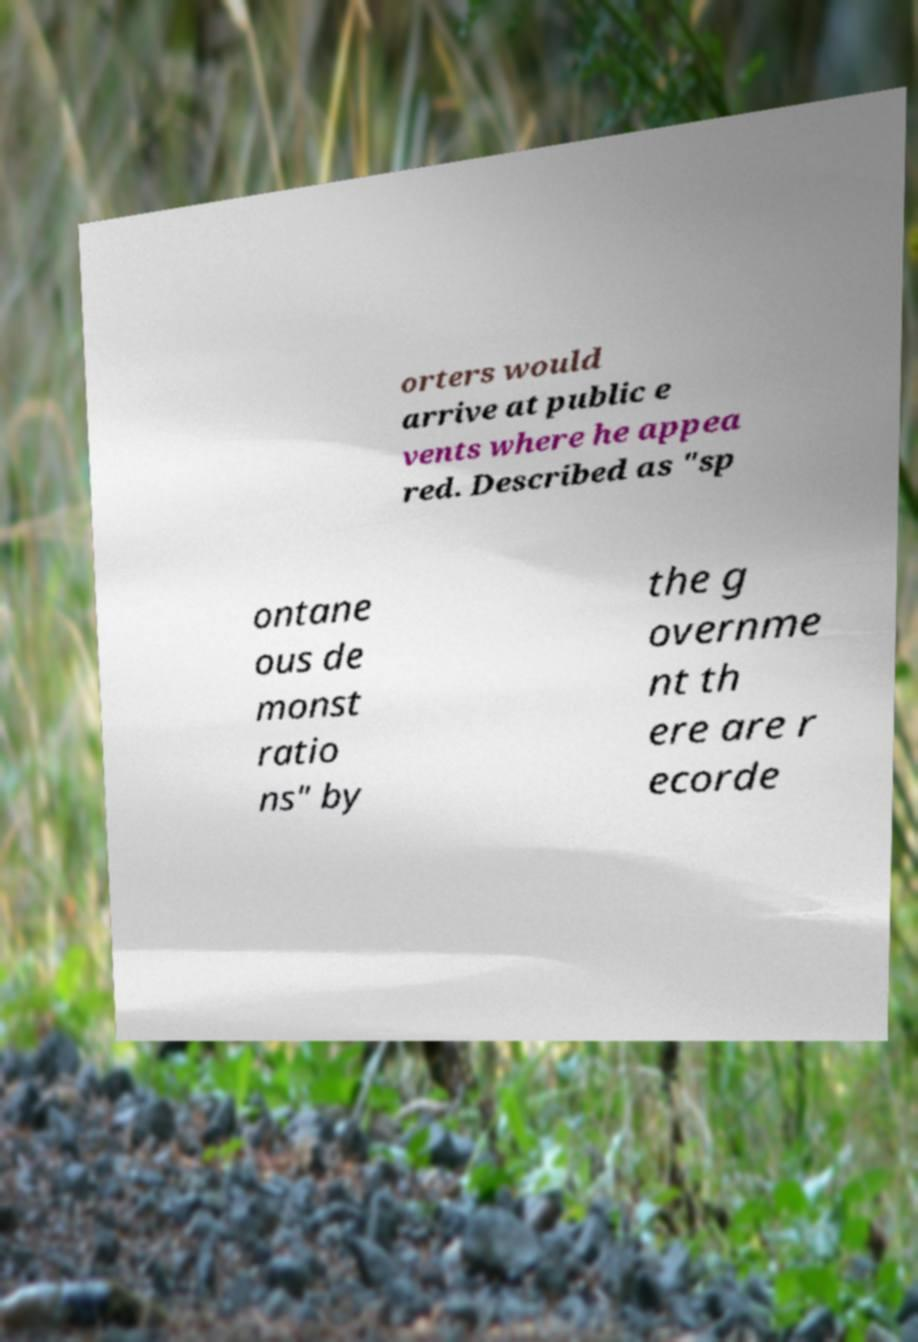Can you read and provide the text displayed in the image?This photo seems to have some interesting text. Can you extract and type it out for me? orters would arrive at public e vents where he appea red. Described as "sp ontane ous de monst ratio ns" by the g overnme nt th ere are r ecorde 